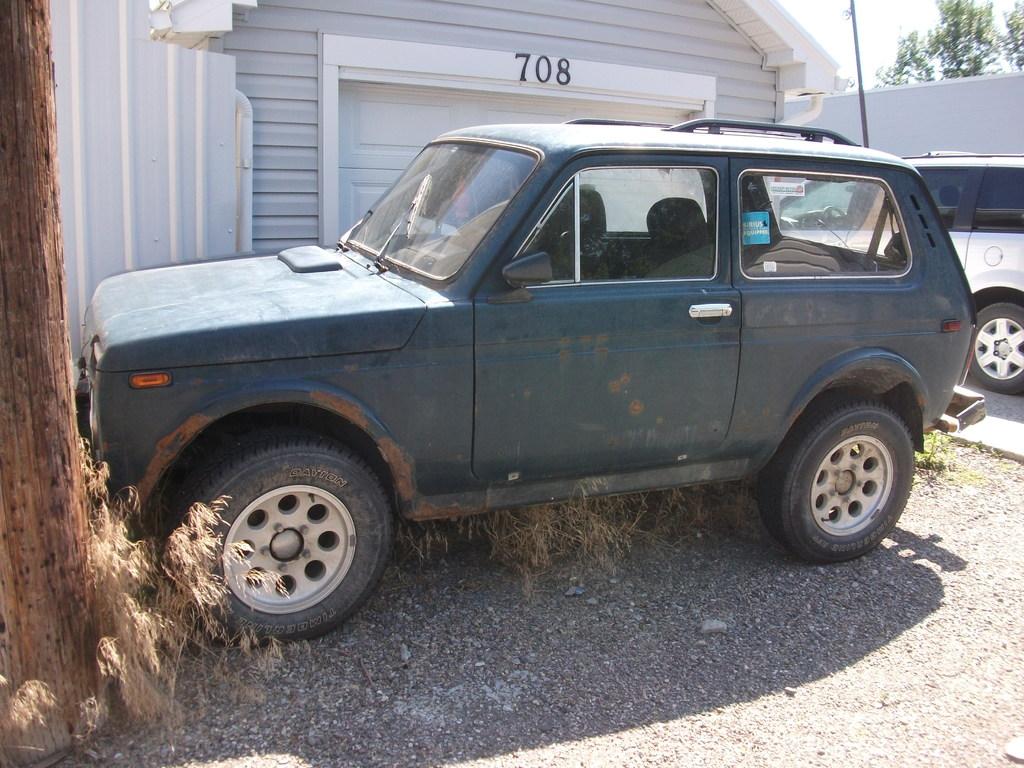What is the house number?
Offer a terse response. 708. What is written on the blue sticker in the left side window?
Make the answer very short. Sirius equipped. 